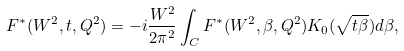<formula> <loc_0><loc_0><loc_500><loc_500>F ^ { * } ( W ^ { 2 } , t , Q ^ { 2 } ) = - i \frac { W ^ { 2 } } { 2 \pi ^ { 2 } } \int _ { C } F ^ { * } ( W ^ { 2 } , \beta , Q ^ { 2 } ) K _ { 0 } ( \sqrt { t \beta } ) d \beta ,</formula> 